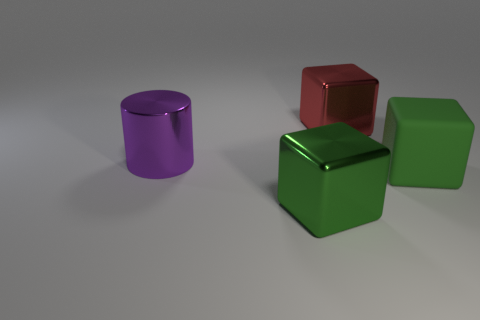Add 3 tiny brown metal things. How many objects exist? 7 Subtract all cylinders. How many objects are left? 3 Subtract 0 red balls. How many objects are left? 4 Subtract all brown shiny cylinders. Subtract all large red things. How many objects are left? 3 Add 1 big metallic things. How many big metallic things are left? 4 Add 4 red metal cubes. How many red metal cubes exist? 5 